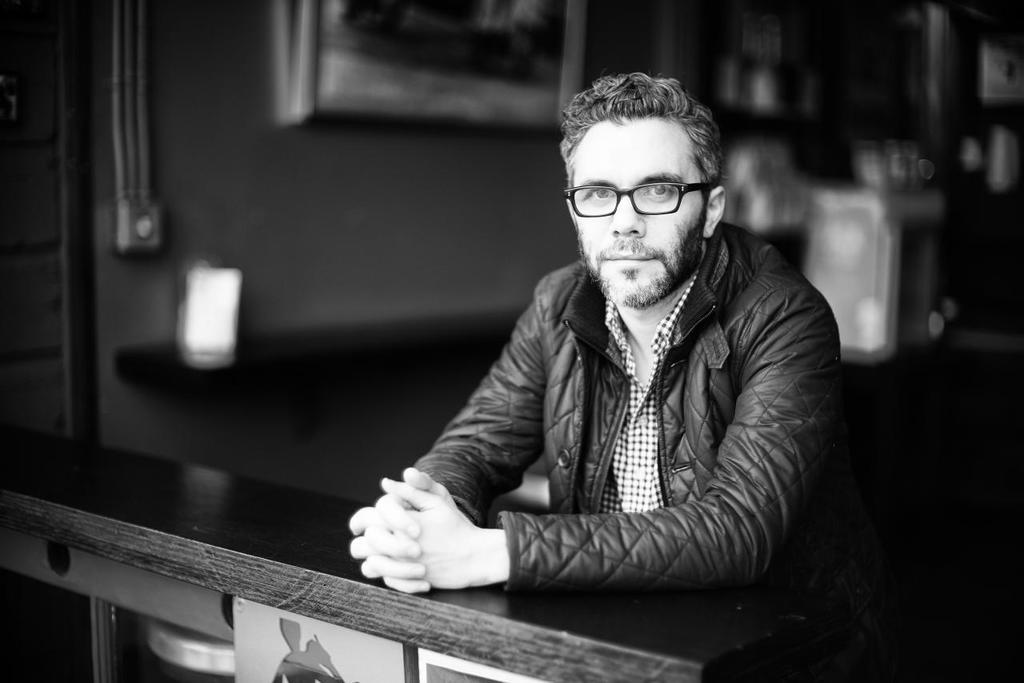Who is the main subject in the image? There is a man in the image. What is the man doing in the image? The man is standing in the image. What accessories is the man wearing in the image? The man is wearing glasses (specs) and a jacket in the image. Reasoning: Let's think step by step by step in order to produce the conversation. We start by identifying the main subject in the image, which is the man. Then, we describe his actions and the accessories he is wearing, which are glasses (specs) and a jacket. Each question is designed to elicit a specific detail about the image that is known from the provided facts. Absurd Question/Answer: What type of gun is the man holding in the image? There is no gun present in the image; the man is only wearing glasses (specs) and a jacket. Is there a cat sitting on the man's shoulder in the image? There is no cat present in the image; the man is only wearing glasses (specs) and a jacket. 